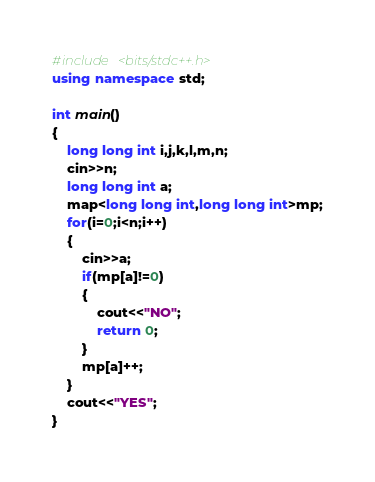Convert code to text. <code><loc_0><loc_0><loc_500><loc_500><_C++_>#include <bits/stdc++.h>
using namespace std;
 
int main()
{
	long long int i,j,k,l,m,n;
	cin>>n;
	long long int a;
	map<long long int,long long int>mp;
	for(i=0;i<n;i++)
	{
		cin>>a;
		if(mp[a]!=0)
		{
			cout<<"NO";
			return 0;
		}
		mp[a]++;
	}
	cout<<"YES";
}</code> 